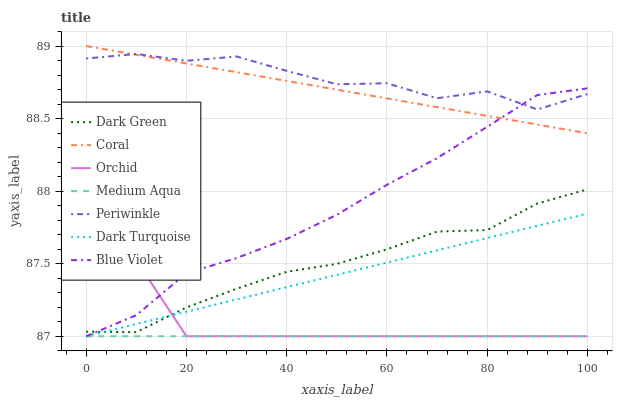Does Medium Aqua have the minimum area under the curve?
Answer yes or no. Yes. Does Periwinkle have the maximum area under the curve?
Answer yes or no. Yes. Does Coral have the minimum area under the curve?
Answer yes or no. No. Does Coral have the maximum area under the curve?
Answer yes or no. No. Is Dark Turquoise the smoothest?
Answer yes or no. Yes. Is Periwinkle the roughest?
Answer yes or no. Yes. Is Coral the smoothest?
Answer yes or no. No. Is Coral the roughest?
Answer yes or no. No. Does Dark Turquoise have the lowest value?
Answer yes or no. Yes. Does Coral have the lowest value?
Answer yes or no. No. Does Coral have the highest value?
Answer yes or no. Yes. Does Periwinkle have the highest value?
Answer yes or no. No. Is Dark Turquoise less than Periwinkle?
Answer yes or no. Yes. Is Periwinkle greater than Medium Aqua?
Answer yes or no. Yes. Does Dark Turquoise intersect Orchid?
Answer yes or no. Yes. Is Dark Turquoise less than Orchid?
Answer yes or no. No. Is Dark Turquoise greater than Orchid?
Answer yes or no. No. Does Dark Turquoise intersect Periwinkle?
Answer yes or no. No. 